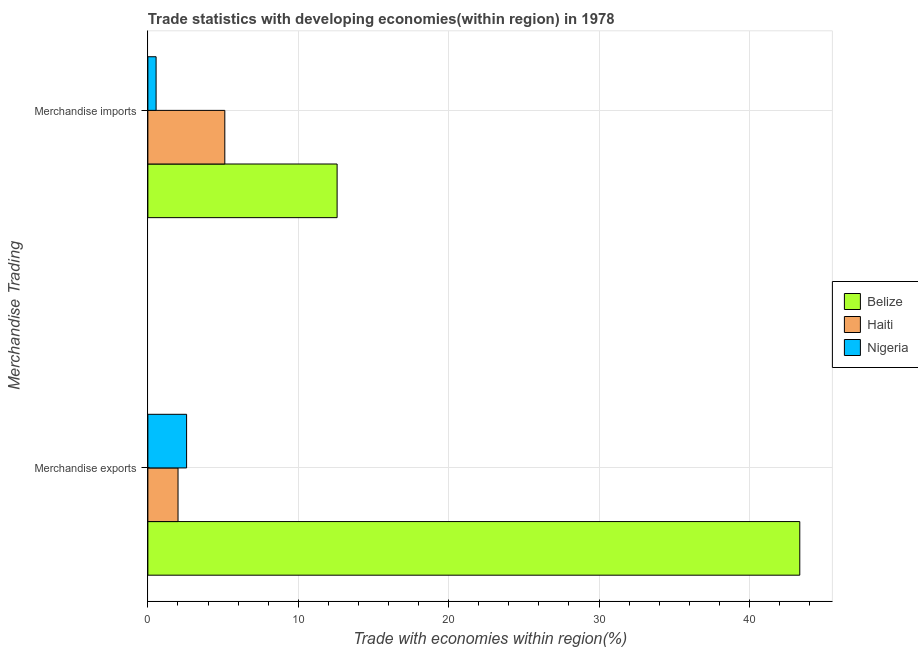How many different coloured bars are there?
Provide a short and direct response. 3. Are the number of bars per tick equal to the number of legend labels?
Your response must be concise. Yes. Are the number of bars on each tick of the Y-axis equal?
Offer a terse response. Yes. How many bars are there on the 2nd tick from the top?
Make the answer very short. 3. How many bars are there on the 1st tick from the bottom?
Make the answer very short. 3. What is the label of the 1st group of bars from the top?
Keep it short and to the point. Merchandise imports. What is the merchandise imports in Nigeria?
Keep it short and to the point. 0.55. Across all countries, what is the maximum merchandise exports?
Your response must be concise. 43.35. Across all countries, what is the minimum merchandise exports?
Your response must be concise. 2.01. In which country was the merchandise exports maximum?
Give a very brief answer. Belize. In which country was the merchandise exports minimum?
Keep it short and to the point. Haiti. What is the total merchandise imports in the graph?
Your response must be concise. 18.25. What is the difference between the merchandise imports in Belize and that in Haiti?
Give a very brief answer. 7.47. What is the difference between the merchandise imports in Belize and the merchandise exports in Nigeria?
Provide a succinct answer. 10.01. What is the average merchandise exports per country?
Make the answer very short. 15.98. What is the difference between the merchandise exports and merchandise imports in Haiti?
Provide a succinct answer. -3.11. In how many countries, is the merchandise imports greater than 22 %?
Your answer should be compact. 0. What is the ratio of the merchandise imports in Belize to that in Haiti?
Offer a very short reply. 2.46. Is the merchandise exports in Haiti less than that in Belize?
Give a very brief answer. Yes. In how many countries, is the merchandise imports greater than the average merchandise imports taken over all countries?
Give a very brief answer. 1. What does the 1st bar from the top in Merchandise imports represents?
Give a very brief answer. Nigeria. What does the 3rd bar from the bottom in Merchandise imports represents?
Provide a short and direct response. Nigeria. Are all the bars in the graph horizontal?
Provide a short and direct response. Yes. Are the values on the major ticks of X-axis written in scientific E-notation?
Make the answer very short. No. Does the graph contain any zero values?
Ensure brevity in your answer.  No. Does the graph contain grids?
Provide a short and direct response. Yes. Where does the legend appear in the graph?
Make the answer very short. Center right. How many legend labels are there?
Your answer should be compact. 3. How are the legend labels stacked?
Offer a very short reply. Vertical. What is the title of the graph?
Make the answer very short. Trade statistics with developing economies(within region) in 1978. What is the label or title of the X-axis?
Keep it short and to the point. Trade with economies within region(%). What is the label or title of the Y-axis?
Offer a very short reply. Merchandise Trading. What is the Trade with economies within region(%) in Belize in Merchandise exports?
Your response must be concise. 43.35. What is the Trade with economies within region(%) of Haiti in Merchandise exports?
Ensure brevity in your answer.  2.01. What is the Trade with economies within region(%) in Nigeria in Merchandise exports?
Your answer should be very brief. 2.58. What is the Trade with economies within region(%) in Belize in Merchandise imports?
Make the answer very short. 12.58. What is the Trade with economies within region(%) in Haiti in Merchandise imports?
Your answer should be compact. 5.12. What is the Trade with economies within region(%) of Nigeria in Merchandise imports?
Offer a terse response. 0.55. Across all Merchandise Trading, what is the maximum Trade with economies within region(%) in Belize?
Your response must be concise. 43.35. Across all Merchandise Trading, what is the maximum Trade with economies within region(%) of Haiti?
Your answer should be very brief. 5.12. Across all Merchandise Trading, what is the maximum Trade with economies within region(%) in Nigeria?
Offer a very short reply. 2.58. Across all Merchandise Trading, what is the minimum Trade with economies within region(%) in Belize?
Offer a terse response. 12.58. Across all Merchandise Trading, what is the minimum Trade with economies within region(%) in Haiti?
Make the answer very short. 2.01. Across all Merchandise Trading, what is the minimum Trade with economies within region(%) of Nigeria?
Offer a terse response. 0.55. What is the total Trade with economies within region(%) of Belize in the graph?
Ensure brevity in your answer.  55.93. What is the total Trade with economies within region(%) of Haiti in the graph?
Make the answer very short. 7.12. What is the total Trade with economies within region(%) in Nigeria in the graph?
Your response must be concise. 3.12. What is the difference between the Trade with economies within region(%) in Belize in Merchandise exports and that in Merchandise imports?
Your answer should be very brief. 30.77. What is the difference between the Trade with economies within region(%) of Haiti in Merchandise exports and that in Merchandise imports?
Your answer should be compact. -3.11. What is the difference between the Trade with economies within region(%) of Nigeria in Merchandise exports and that in Merchandise imports?
Offer a terse response. 2.03. What is the difference between the Trade with economies within region(%) of Belize in Merchandise exports and the Trade with economies within region(%) of Haiti in Merchandise imports?
Make the answer very short. 38.23. What is the difference between the Trade with economies within region(%) in Belize in Merchandise exports and the Trade with economies within region(%) in Nigeria in Merchandise imports?
Your response must be concise. 42.8. What is the difference between the Trade with economies within region(%) in Haiti in Merchandise exports and the Trade with economies within region(%) in Nigeria in Merchandise imports?
Ensure brevity in your answer.  1.46. What is the average Trade with economies within region(%) of Belize per Merchandise Trading?
Keep it short and to the point. 27.97. What is the average Trade with economies within region(%) in Haiti per Merchandise Trading?
Your answer should be compact. 3.56. What is the average Trade with economies within region(%) of Nigeria per Merchandise Trading?
Provide a short and direct response. 1.56. What is the difference between the Trade with economies within region(%) of Belize and Trade with economies within region(%) of Haiti in Merchandise exports?
Your answer should be compact. 41.34. What is the difference between the Trade with economies within region(%) of Belize and Trade with economies within region(%) of Nigeria in Merchandise exports?
Your response must be concise. 40.77. What is the difference between the Trade with economies within region(%) in Haiti and Trade with economies within region(%) in Nigeria in Merchandise exports?
Your response must be concise. -0.57. What is the difference between the Trade with economies within region(%) in Belize and Trade with economies within region(%) in Haiti in Merchandise imports?
Your response must be concise. 7.47. What is the difference between the Trade with economies within region(%) of Belize and Trade with economies within region(%) of Nigeria in Merchandise imports?
Keep it short and to the point. 12.04. What is the difference between the Trade with economies within region(%) in Haiti and Trade with economies within region(%) in Nigeria in Merchandise imports?
Ensure brevity in your answer.  4.57. What is the ratio of the Trade with economies within region(%) of Belize in Merchandise exports to that in Merchandise imports?
Give a very brief answer. 3.44. What is the ratio of the Trade with economies within region(%) in Haiti in Merchandise exports to that in Merchandise imports?
Your answer should be very brief. 0.39. What is the ratio of the Trade with economies within region(%) in Nigeria in Merchandise exports to that in Merchandise imports?
Your answer should be very brief. 4.71. What is the difference between the highest and the second highest Trade with economies within region(%) in Belize?
Provide a succinct answer. 30.77. What is the difference between the highest and the second highest Trade with economies within region(%) of Haiti?
Provide a short and direct response. 3.11. What is the difference between the highest and the second highest Trade with economies within region(%) of Nigeria?
Offer a terse response. 2.03. What is the difference between the highest and the lowest Trade with economies within region(%) in Belize?
Ensure brevity in your answer.  30.77. What is the difference between the highest and the lowest Trade with economies within region(%) in Haiti?
Provide a short and direct response. 3.11. What is the difference between the highest and the lowest Trade with economies within region(%) in Nigeria?
Your response must be concise. 2.03. 